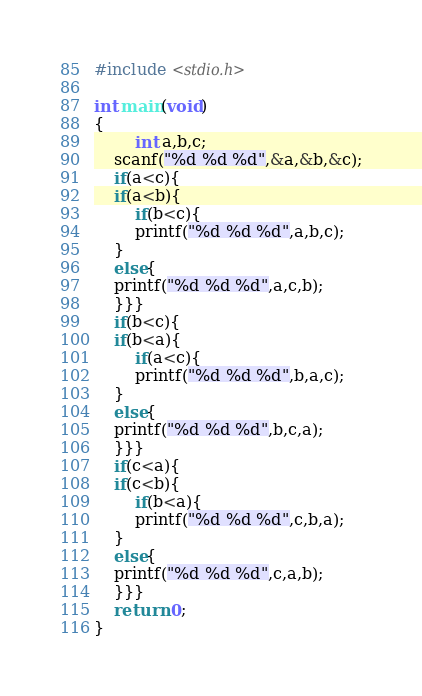Convert code to text. <code><loc_0><loc_0><loc_500><loc_500><_C_>#include <stdio.h>

int main(void)
{
		int a,b,c;
	scanf("%d %d %d",&a,&b,&c);
	if(a<c){
	if(a<b){
		if(b<c){
		printf("%d %d %d",a,b,c);
	}
	else{
	printf("%d %d %d",a,c,b);
	}}}
	if(b<c){
	if(b<a){
		if(a<c){
		printf("%d %d %d",b,a,c);
	}
	else{
	printf("%d %d %d",b,c,a);
	}}}
	if(c<a){
	if(c<b){
		if(b<a){
		printf("%d %d %d",c,b,a);
	}
	else{
	printf("%d %d %d",c,a,b);
	}}}
	return 0;
}</code> 